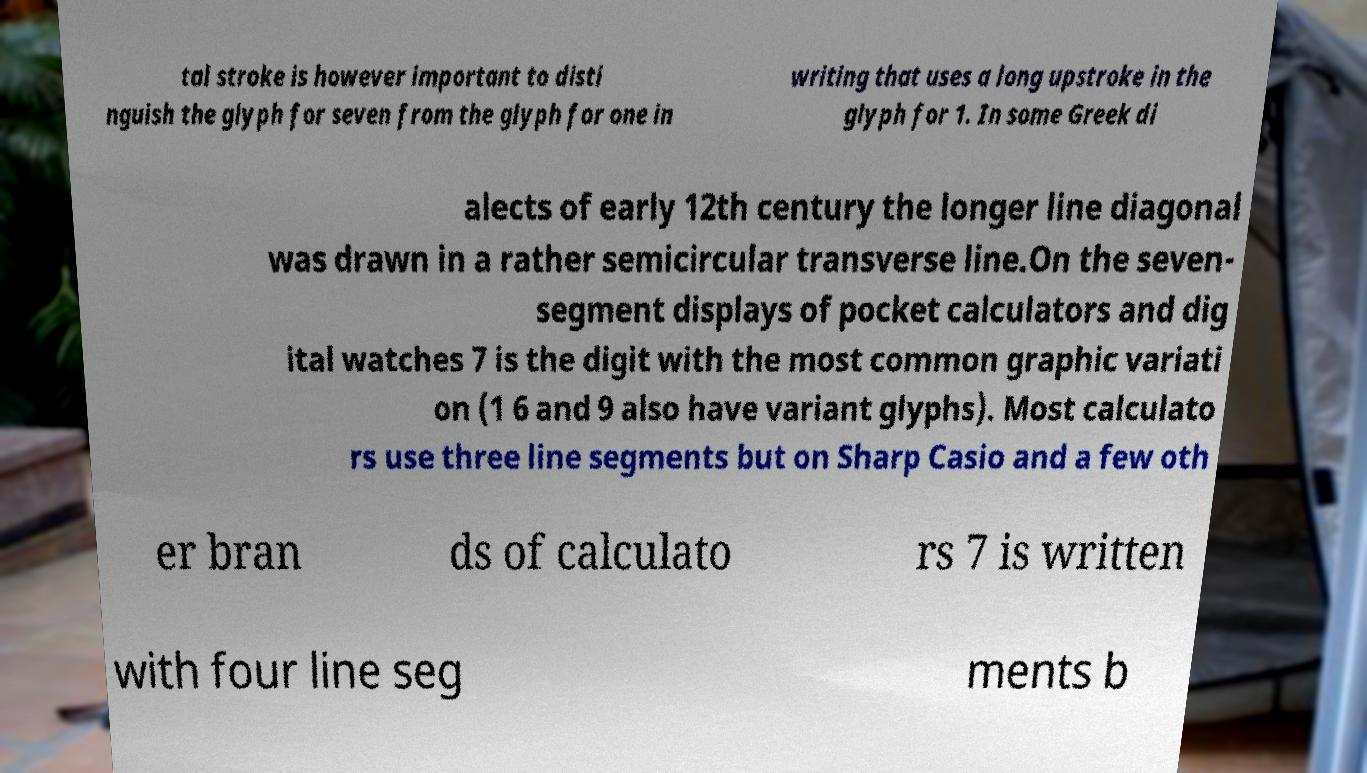Could you extract and type out the text from this image? tal stroke is however important to disti nguish the glyph for seven from the glyph for one in writing that uses a long upstroke in the glyph for 1. In some Greek di alects of early 12th century the longer line diagonal was drawn in a rather semicircular transverse line.On the seven- segment displays of pocket calculators and dig ital watches 7 is the digit with the most common graphic variati on (1 6 and 9 also have variant glyphs). Most calculato rs use three line segments but on Sharp Casio and a few oth er bran ds of calculato rs 7 is written with four line seg ments b 